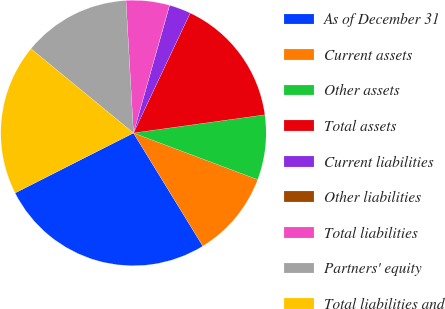<chart> <loc_0><loc_0><loc_500><loc_500><pie_chart><fcel>As of December 31<fcel>Current assets<fcel>Other assets<fcel>Total assets<fcel>Current liabilities<fcel>Other liabilities<fcel>Total liabilities<fcel>Partners' equity<fcel>Total liabilities and<nl><fcel>26.29%<fcel>10.53%<fcel>7.9%<fcel>15.78%<fcel>2.64%<fcel>0.02%<fcel>5.27%<fcel>13.15%<fcel>18.41%<nl></chart> 